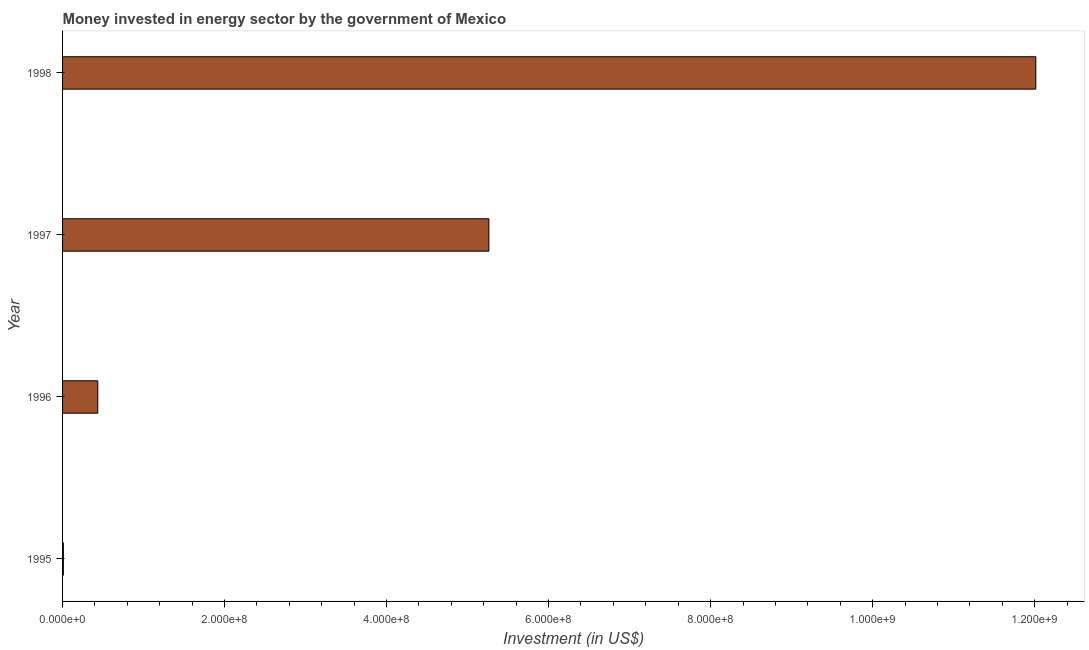Does the graph contain any zero values?
Make the answer very short. No. Does the graph contain grids?
Provide a short and direct response. No. What is the title of the graph?
Keep it short and to the point. Money invested in energy sector by the government of Mexico. What is the label or title of the X-axis?
Ensure brevity in your answer.  Investment (in US$). What is the investment in energy in 1998?
Give a very brief answer. 1.20e+09. Across all years, what is the maximum investment in energy?
Offer a very short reply. 1.20e+09. In which year was the investment in energy maximum?
Provide a succinct answer. 1998. In which year was the investment in energy minimum?
Offer a terse response. 1995. What is the sum of the investment in energy?
Make the answer very short. 1.77e+09. What is the difference between the investment in energy in 1995 and 1998?
Give a very brief answer. -1.20e+09. What is the average investment in energy per year?
Your answer should be compact. 4.43e+08. What is the median investment in energy?
Your response must be concise. 2.85e+08. In how many years, is the investment in energy greater than 720000000 US$?
Keep it short and to the point. 1. What is the ratio of the investment in energy in 1997 to that in 1998?
Provide a short and direct response. 0.44. Is the investment in energy in 1997 less than that in 1998?
Provide a short and direct response. Yes. Is the difference between the investment in energy in 1995 and 1997 greater than the difference between any two years?
Offer a very short reply. No. What is the difference between the highest and the second highest investment in energy?
Offer a very short reply. 6.75e+08. What is the difference between the highest and the lowest investment in energy?
Ensure brevity in your answer.  1.20e+09. In how many years, is the investment in energy greater than the average investment in energy taken over all years?
Your response must be concise. 2. How many bars are there?
Your answer should be very brief. 4. Are the values on the major ticks of X-axis written in scientific E-notation?
Provide a succinct answer. Yes. What is the Investment (in US$) of 1996?
Provide a succinct answer. 4.35e+07. What is the Investment (in US$) of 1997?
Provide a succinct answer. 5.26e+08. What is the Investment (in US$) of 1998?
Provide a short and direct response. 1.20e+09. What is the difference between the Investment (in US$) in 1995 and 1996?
Offer a very short reply. -4.25e+07. What is the difference between the Investment (in US$) in 1995 and 1997?
Give a very brief answer. -5.25e+08. What is the difference between the Investment (in US$) in 1995 and 1998?
Your response must be concise. -1.20e+09. What is the difference between the Investment (in US$) in 1996 and 1997?
Your answer should be very brief. -4.83e+08. What is the difference between the Investment (in US$) in 1996 and 1998?
Give a very brief answer. -1.16e+09. What is the difference between the Investment (in US$) in 1997 and 1998?
Make the answer very short. -6.75e+08. What is the ratio of the Investment (in US$) in 1995 to that in 1996?
Your answer should be very brief. 0.02. What is the ratio of the Investment (in US$) in 1995 to that in 1997?
Keep it short and to the point. 0. What is the ratio of the Investment (in US$) in 1996 to that in 1997?
Ensure brevity in your answer.  0.08. What is the ratio of the Investment (in US$) in 1996 to that in 1998?
Give a very brief answer. 0.04. What is the ratio of the Investment (in US$) in 1997 to that in 1998?
Keep it short and to the point. 0.44. 